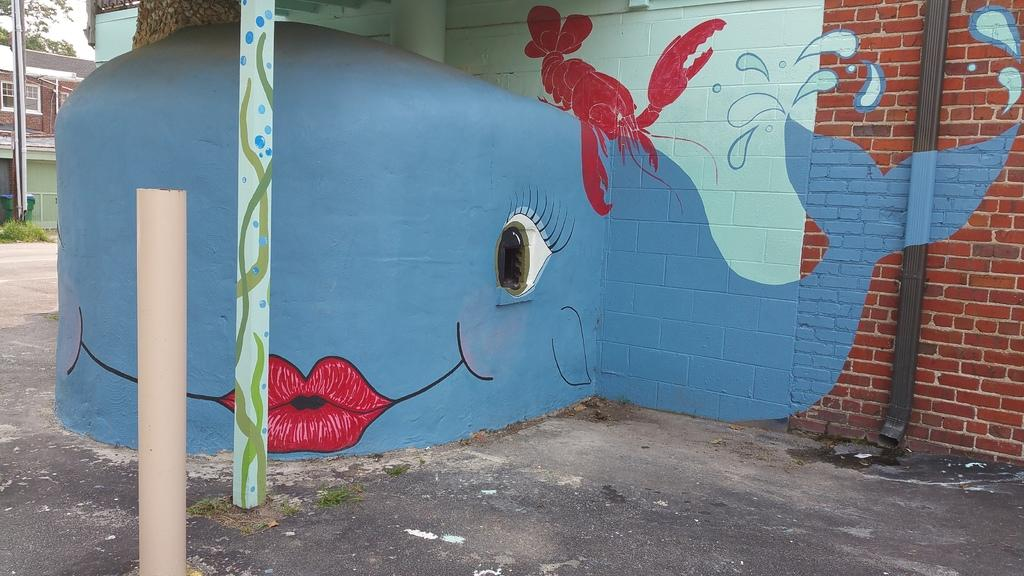What is depicted on the wall in the image? There are paintings on the wall in the image. What can be seen in the left top corner of the image? There are buildings and trees in the left top corner of the image. What type of fruit is hanging from the wall in the image? There is no fruit hanging from the wall in the image; it features paintings on the wall. Is there a glove visible in the image? There is no mention of a glove in the provided facts, so it cannot be determined if one is present in the image. 